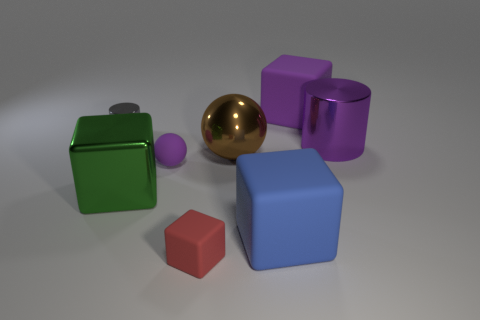Subtract all blue cubes. How many cubes are left? 3 Add 2 big rubber cylinders. How many objects exist? 10 Subtract all balls. How many objects are left? 6 Subtract 0 yellow cubes. How many objects are left? 8 Subtract all large purple matte objects. Subtract all small purple spheres. How many objects are left? 6 Add 7 big rubber objects. How many big rubber objects are left? 9 Add 6 large brown balls. How many large brown balls exist? 7 